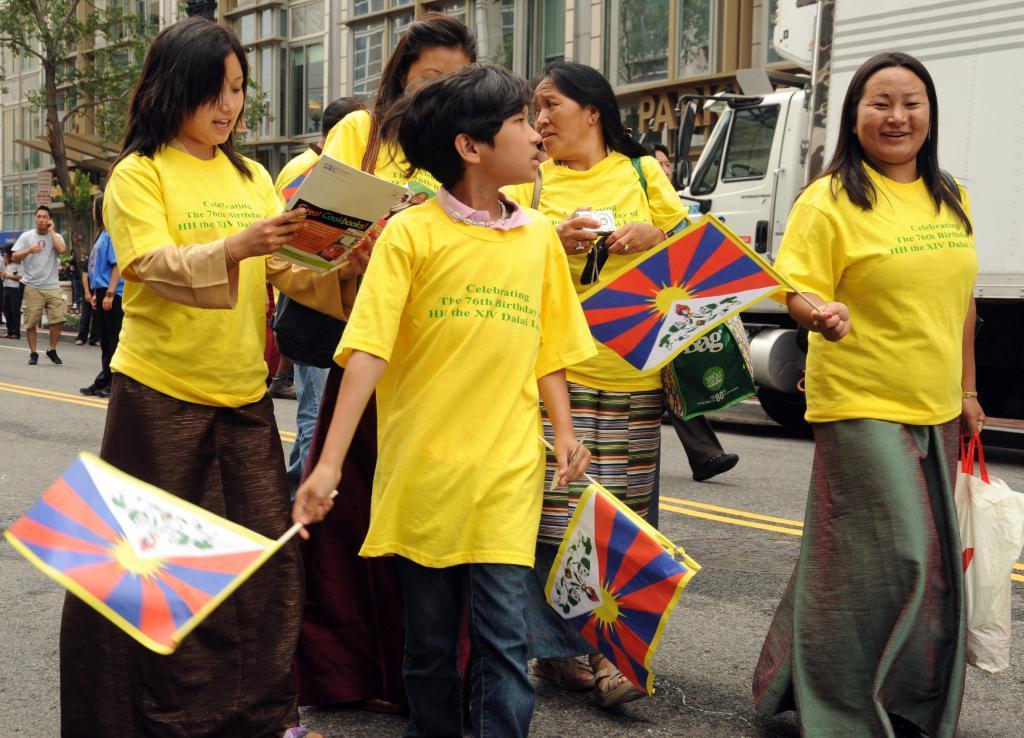How would you summarize this image in a sentence or two? In the image there are few ladies in yellow t-shirt holding flags walking on the road and behind them there is a building with truck and many people walking on it along with a tree on the left side. 